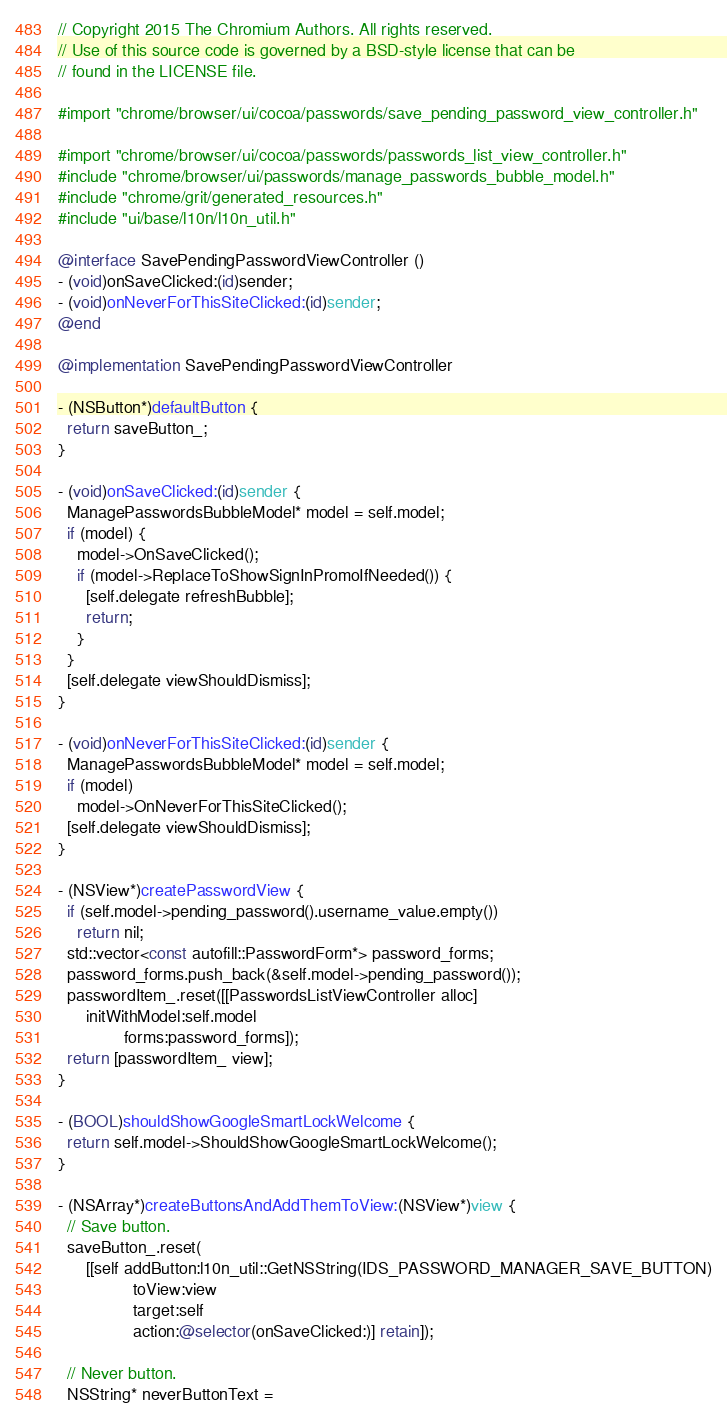Convert code to text. <code><loc_0><loc_0><loc_500><loc_500><_ObjectiveC_>// Copyright 2015 The Chromium Authors. All rights reserved.
// Use of this source code is governed by a BSD-style license that can be
// found in the LICENSE file.

#import "chrome/browser/ui/cocoa/passwords/save_pending_password_view_controller.h"

#import "chrome/browser/ui/cocoa/passwords/passwords_list_view_controller.h"
#include "chrome/browser/ui/passwords/manage_passwords_bubble_model.h"
#include "chrome/grit/generated_resources.h"
#include "ui/base/l10n/l10n_util.h"

@interface SavePendingPasswordViewController ()
- (void)onSaveClicked:(id)sender;
- (void)onNeverForThisSiteClicked:(id)sender;
@end

@implementation SavePendingPasswordViewController

- (NSButton*)defaultButton {
  return saveButton_;
}

- (void)onSaveClicked:(id)sender {
  ManagePasswordsBubbleModel* model = self.model;
  if (model) {
    model->OnSaveClicked();
    if (model->ReplaceToShowSignInPromoIfNeeded()) {
      [self.delegate refreshBubble];
      return;
    }
  }
  [self.delegate viewShouldDismiss];
}

- (void)onNeverForThisSiteClicked:(id)sender {
  ManagePasswordsBubbleModel* model = self.model;
  if (model)
    model->OnNeverForThisSiteClicked();
  [self.delegate viewShouldDismiss];
}

- (NSView*)createPasswordView {
  if (self.model->pending_password().username_value.empty())
    return nil;
  std::vector<const autofill::PasswordForm*> password_forms;
  password_forms.push_back(&self.model->pending_password());
  passwordItem_.reset([[PasswordsListViewController alloc]
      initWithModel:self.model
              forms:password_forms]);
  return [passwordItem_ view];
}

- (BOOL)shouldShowGoogleSmartLockWelcome {
  return self.model->ShouldShowGoogleSmartLockWelcome();
}

- (NSArray*)createButtonsAndAddThemToView:(NSView*)view {
  // Save button.
  saveButton_.reset(
      [[self addButton:l10n_util::GetNSString(IDS_PASSWORD_MANAGER_SAVE_BUTTON)
                toView:view
                target:self
                action:@selector(onSaveClicked:)] retain]);

  // Never button.
  NSString* neverButtonText =</code> 